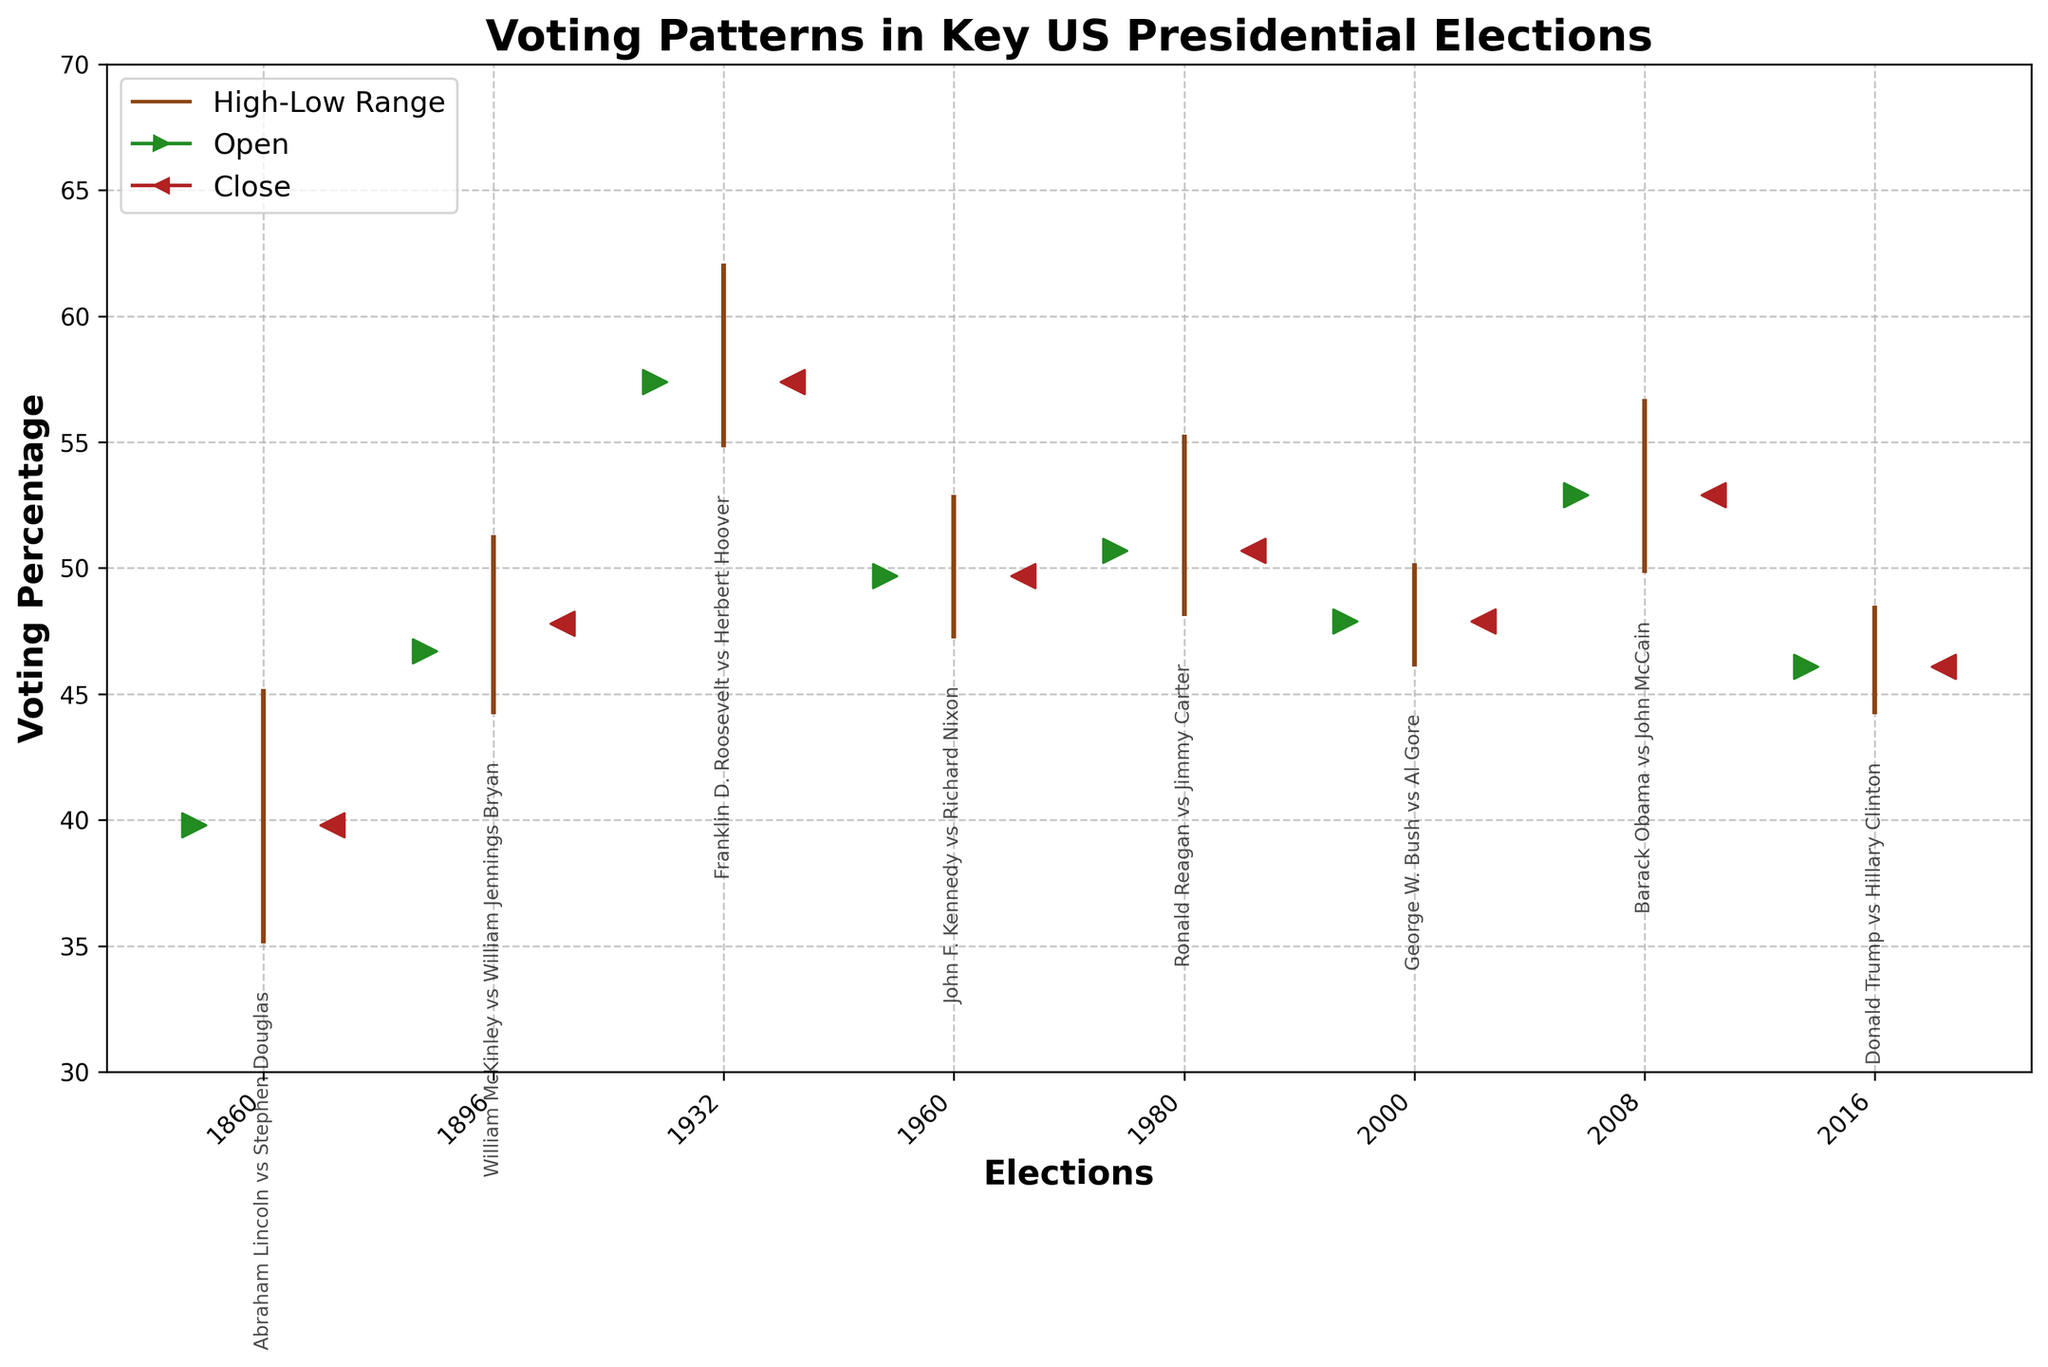What is the title of the figure? The title of the figure can be found at the top of the plot. It generally provides a brief summary of what the chart is about. In this case, it is clearly marked on top.
Answer: Voting Patterns in Key US Presidential Elections Which election had the highest 'High' value on the chart? The 'High' value is represented by the top end of the vertical line in each segment. By looking for the highest point on the chart, we see that the 2008 election (Barack Obama vs. John McCain) has the highest 'High' value of 56.7.
Answer: 2008 (Barack Obama vs. John McCain) Which election had a 'Close' value higher than its 'Open' value? The 'Close' value is represented by the "<" marker, and the 'Open' value is represented by the ">" marker. By comparing both markers visually for each election, the 1896 election (William McKinley vs. William Jennings Bryan) has a 'Close' value of 47.8 which is higher than its 'Open' value of 46.7.
Answer: 1896 (William McKinley vs. William Jennings Bryan) What is the range of 'Low' values observed in the chart? The 'Low' value is the bottom end of the vertical line in each segment. By checking all the 'Low' markers, the minimum 'Low' value is 35.1 (1860) and the maximum 'Low' value is 54.8 (1932). The range is calculated as 54.8 - 35.1.
Answer: 19.7 Which election had the smallest difference between its 'High' and 'Low' values? The difference between 'High' and 'Low' values is calculated for each segment. The smallest difference is for an election where the vertical line is the shortest. By calculation, 2016 (Donald Trump vs Hillary Clinton) has a high of 48.5 and a low of 44.2, resulting in a difference of 48.5 - 44.2 = 4.3.
Answer: 2016 (Donald Trump vs. Hillary Clinton) How many elections had a 'Close' value of exactly the same as the 'Open' value? Both 'Close' and 'Open' values are represented by "<" and ">" markers respectively. By comparing visually, the elections of 1860, 1932, 1960, 1980, 2000, 2008, and 2016 show the close and open markers at the same position.
Answer: 7 Which election had the second highest 'Open' value? 'Open' values are indicated by the ">" markers. Finding the second largest involves noting all opening values: 46.7 (1896), 47.9 (2000), 49.7 (1960), 50.7 (1980), 52.9 (2008), 39.8 (1860), 46.1 (2016). The second highest after 52.9 (2008) is 50.7 (1980).
Answer: 1980 (Ronald Reagan vs. Jimmy Carter) How much higher was the 'High' value in the 2008 election compared to the 1896 election? The 'High' value for 2008 is 56.7 and for 1896 is 51.3. By subtracting the values, 56.7 - 51.3 gives us the difference.
Answer: 5.4 What do the vertical lines represent in the figure? The vertical lines represent the range between the 'High' and 'Low' values for each election year. The top of the line is the 'High' value and the bottom of the line is the 'Low' value.
Answer: The range between 'High' and 'Low' values 